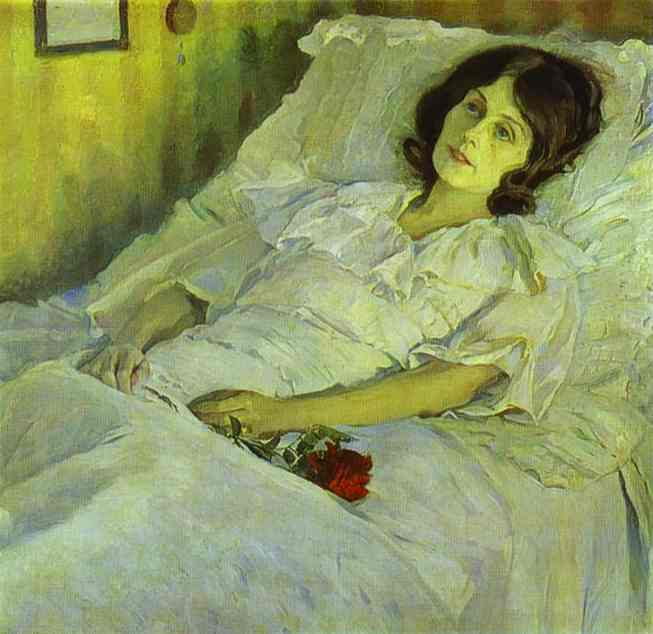Can you describe the main features of this image for me? The image is a captivating oil painting that captures a moment of tranquility and introspection. It features a young woman lying in bed, her hands gently cradling a bouquet of vibrant red flowers. The artist has chosen an impressionist style, characterized by loose brushstrokes that beautifully capture the interplay of light and color. The predominant colors are warm hues of yellow and green, punctuated by the striking red of the flowers and the soft white of the bed linens. This painting is a portrait, a genre of art that focuses on the depiction of a person, often capturing their mood or expression. In this case, the artist has skillfully used color and composition to convey a sense of peaceful solitude. The painting falls into the genre of figurative art, which prioritizes realistic representation of the subject matter. 